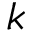Convert formula to latex. <formula><loc_0><loc_0><loc_500><loc_500>k</formula> 